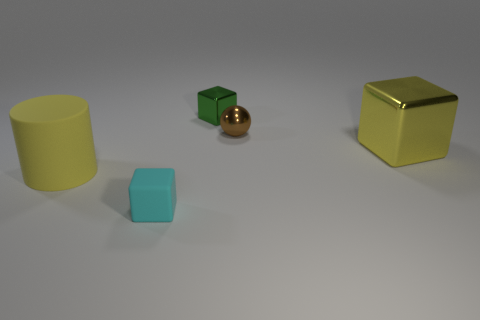What material is the large yellow cube?
Your answer should be very brief. Metal. Are the cyan cube and the tiny green thing made of the same material?
Your answer should be compact. No. What number of matte objects are tiny green things or large brown objects?
Keep it short and to the point. 0. What is the shape of the large yellow thing to the left of the yellow block?
Offer a very short reply. Cylinder. What size is the brown ball that is made of the same material as the small green cube?
Your response must be concise. Small. There is a thing that is in front of the small ball and behind the cylinder; what is its shape?
Make the answer very short. Cube. There is a rubber object in front of the large rubber cylinder; is its color the same as the large cube?
Your answer should be very brief. No. Is the shape of the tiny object that is in front of the big cylinder the same as the metal thing that is right of the small brown metal thing?
Provide a succinct answer. Yes. There is a yellow thing that is on the right side of the small brown shiny sphere; what is its size?
Make the answer very short. Large. There is a rubber thing left of the small block on the left side of the green block; what is its size?
Offer a terse response. Large. 